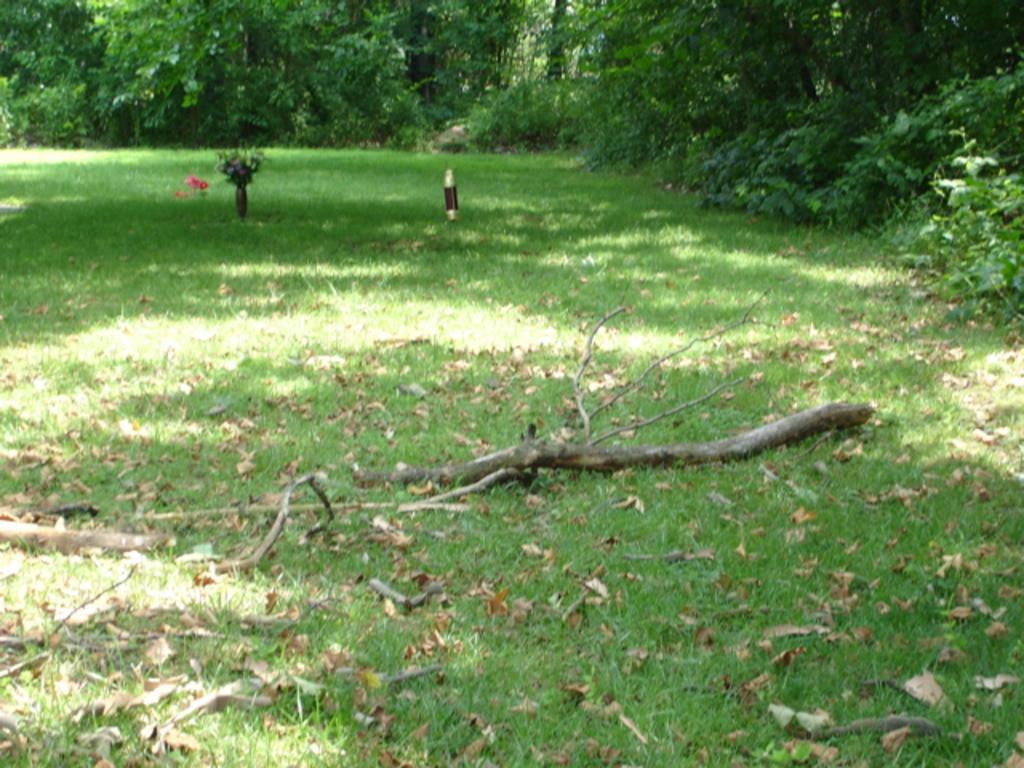In one or two sentences, can you explain what this image depicts? In this image we can see some grass, flower vases which are on the ground and in the background of the image there are some trees. 